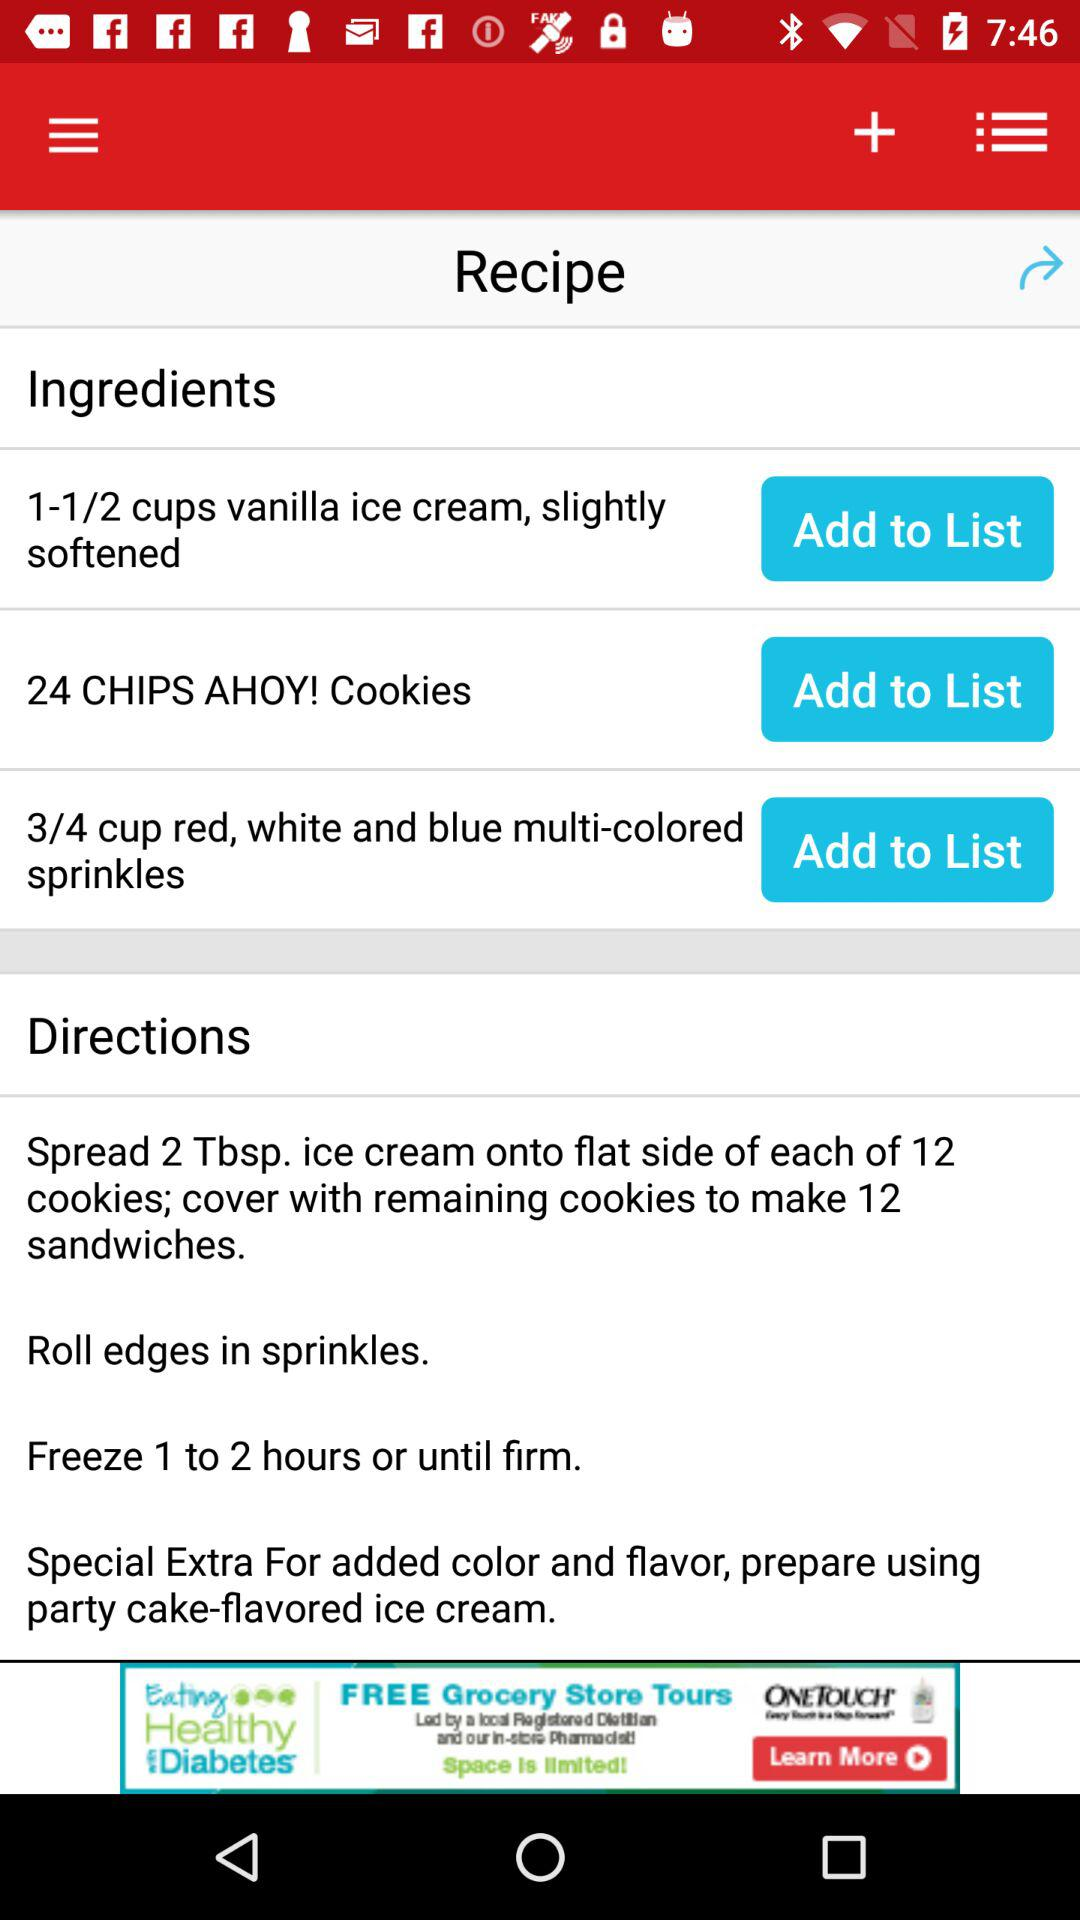For how long to freeze? Freeze for 1 to 2 hours or until firm. 